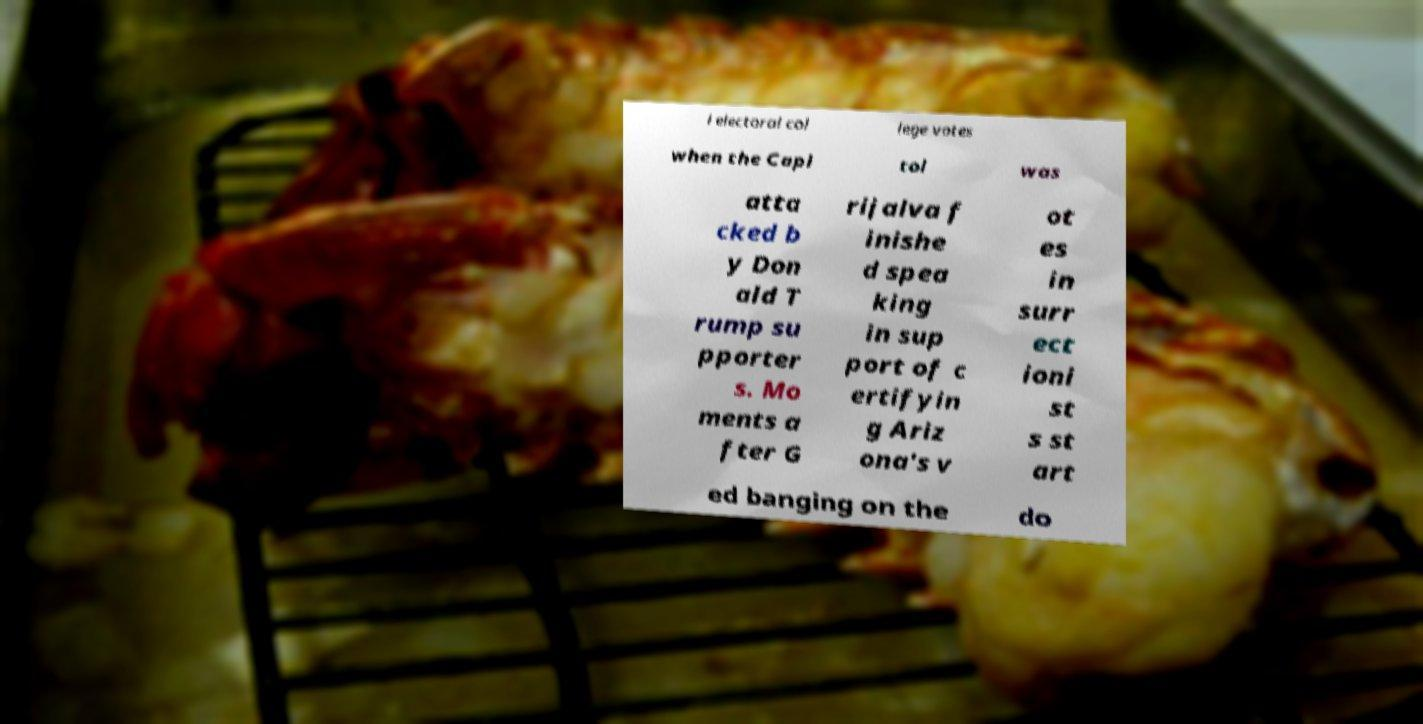Can you read and provide the text displayed in the image?This photo seems to have some interesting text. Can you extract and type it out for me? l electoral col lege votes when the Capi tol was atta cked b y Don ald T rump su pporter s. Mo ments a fter G rijalva f inishe d spea king in sup port of c ertifyin g Ariz ona's v ot es in surr ect ioni st s st art ed banging on the do 